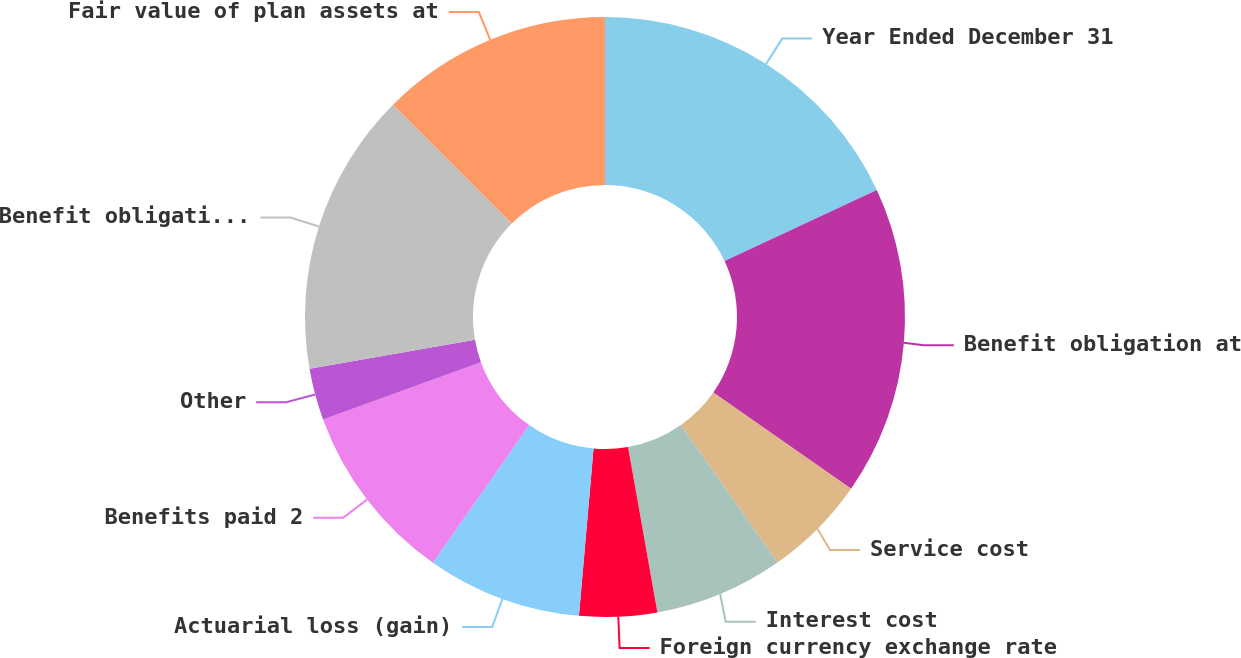Convert chart to OTSL. <chart><loc_0><loc_0><loc_500><loc_500><pie_chart><fcel>Year Ended December 31<fcel>Benefit obligation at<fcel>Service cost<fcel>Interest cost<fcel>Foreign currency exchange rate<fcel>Actuarial loss (gain)<fcel>Benefits paid 2<fcel>Other<fcel>Benefit obligation at end of<fcel>Fair value of plan assets at<nl><fcel>18.04%<fcel>16.65%<fcel>5.56%<fcel>6.95%<fcel>4.18%<fcel>8.34%<fcel>9.72%<fcel>2.79%<fcel>15.27%<fcel>12.49%<nl></chart> 